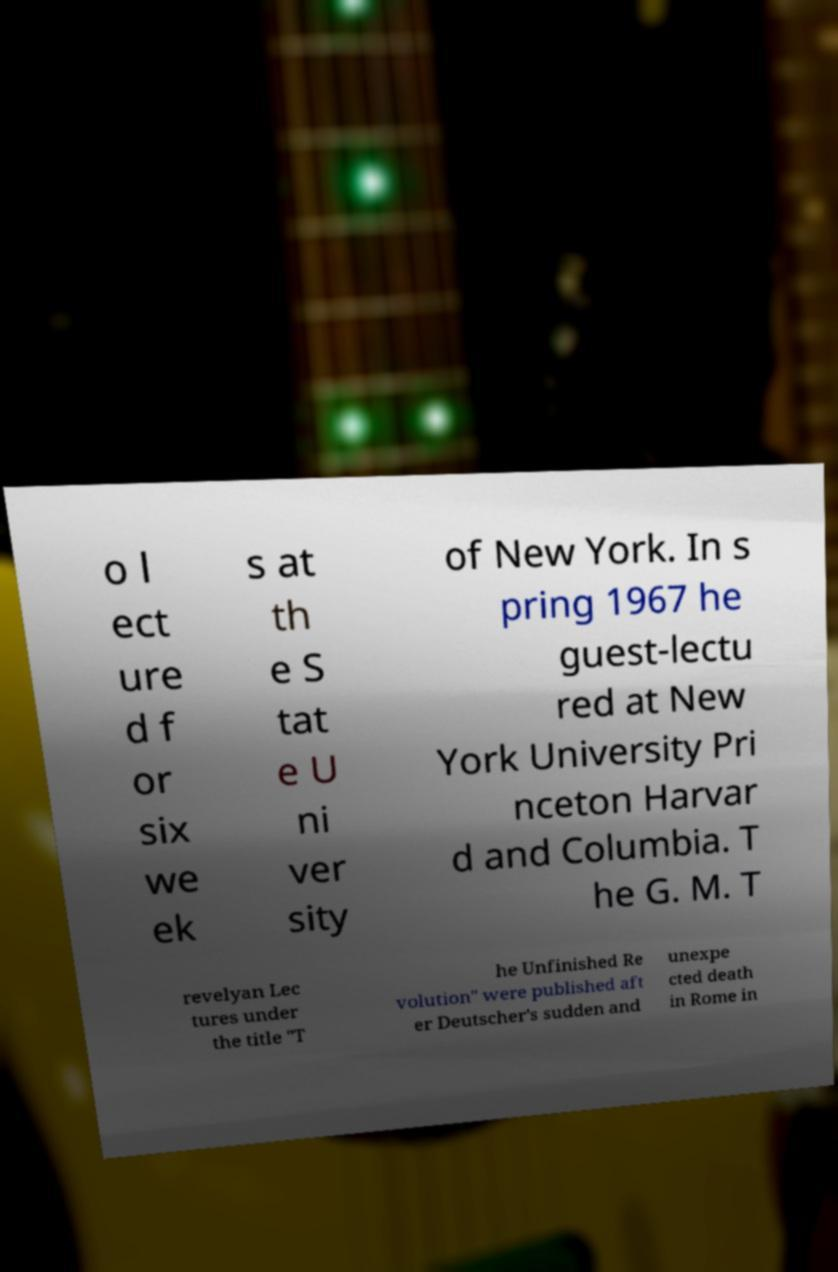Could you extract and type out the text from this image? o l ect ure d f or six we ek s at th e S tat e U ni ver sity of New York. In s pring 1967 he guest-lectu red at New York University Pri nceton Harvar d and Columbia. T he G. M. T revelyan Lec tures under the title "T he Unfinished Re volution" were published aft er Deutscher's sudden and unexpe cted death in Rome in 